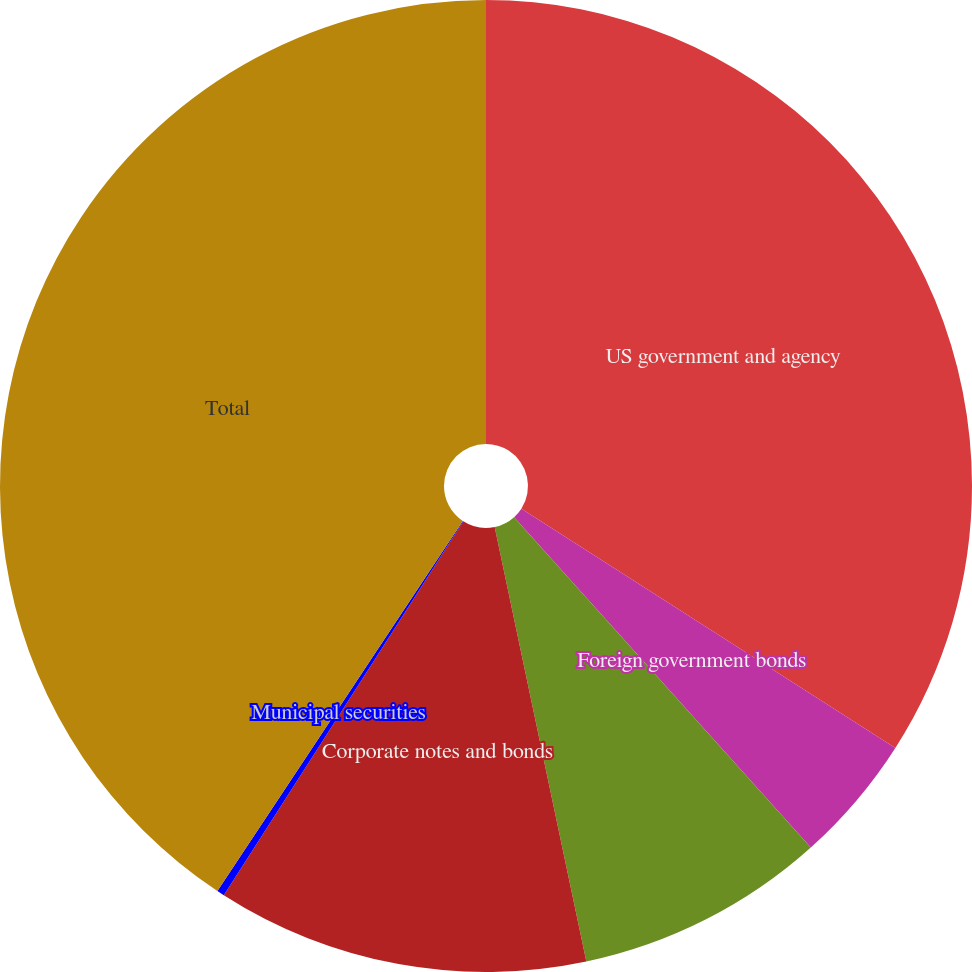<chart> <loc_0><loc_0><loc_500><loc_500><pie_chart><fcel>US government and agency<fcel>Foreign government bonds<fcel>Mortgage- and asset-backed<fcel>Corporate notes and bonds<fcel>Municipal securities<fcel>Total<nl><fcel>34.06%<fcel>4.29%<fcel>8.34%<fcel>12.38%<fcel>0.25%<fcel>40.68%<nl></chart> 